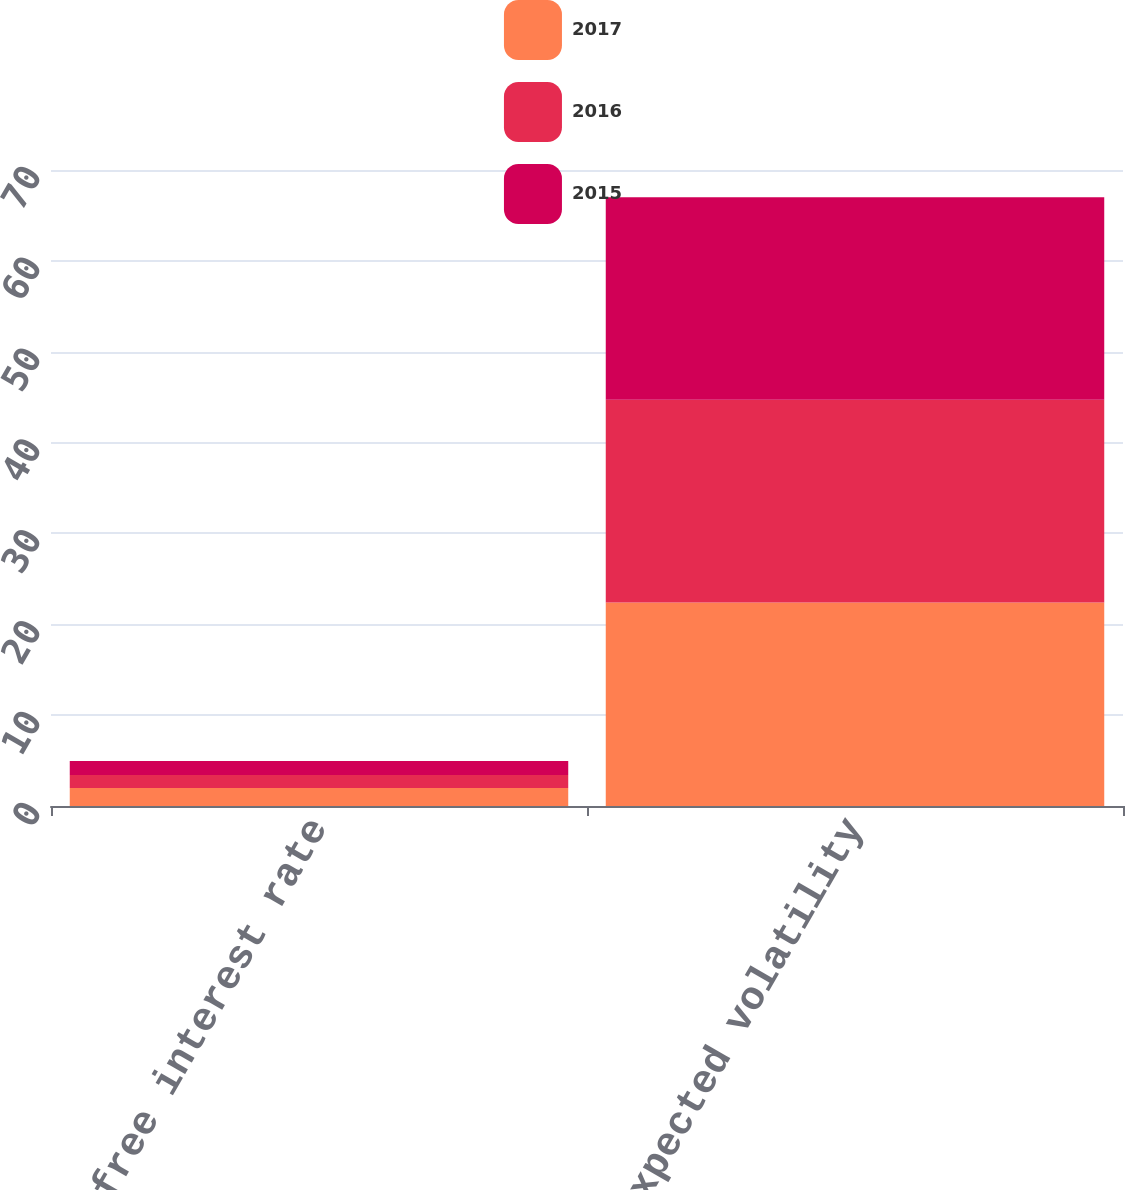Convert chart to OTSL. <chart><loc_0><loc_0><loc_500><loc_500><stacked_bar_chart><ecel><fcel>Risk free interest rate<fcel>Expected volatility<nl><fcel>2017<fcel>1.98<fcel>22.4<nl><fcel>2016<fcel>1.44<fcel>22.3<nl><fcel>2015<fcel>1.52<fcel>22.3<nl></chart> 